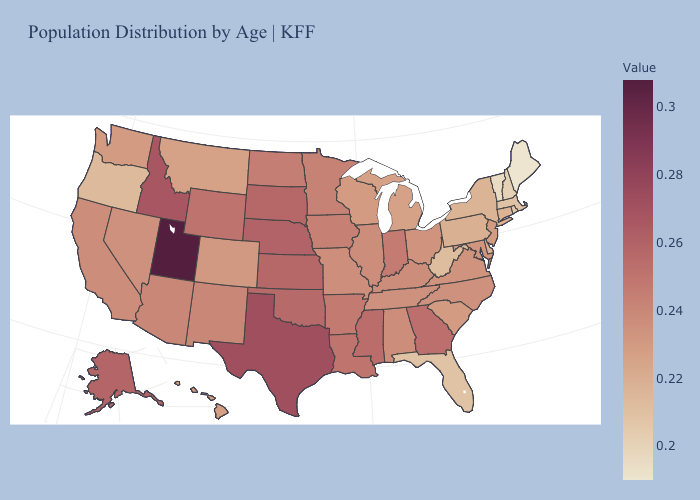Is the legend a continuous bar?
Write a very short answer. Yes. Which states have the lowest value in the USA?
Be succinct. Maine. Does Minnesota have a higher value than Wisconsin?
Short answer required. Yes. Which states have the lowest value in the South?
Quick response, please. Florida. Does Florida have the lowest value in the South?
Be succinct. Yes. Among the states that border Iowa , does Wisconsin have the lowest value?
Be succinct. Yes. Does the map have missing data?
Concise answer only. No. Does Nebraska have the highest value in the MidWest?
Give a very brief answer. Yes. Does Alaska have a lower value than Texas?
Answer briefly. Yes. 